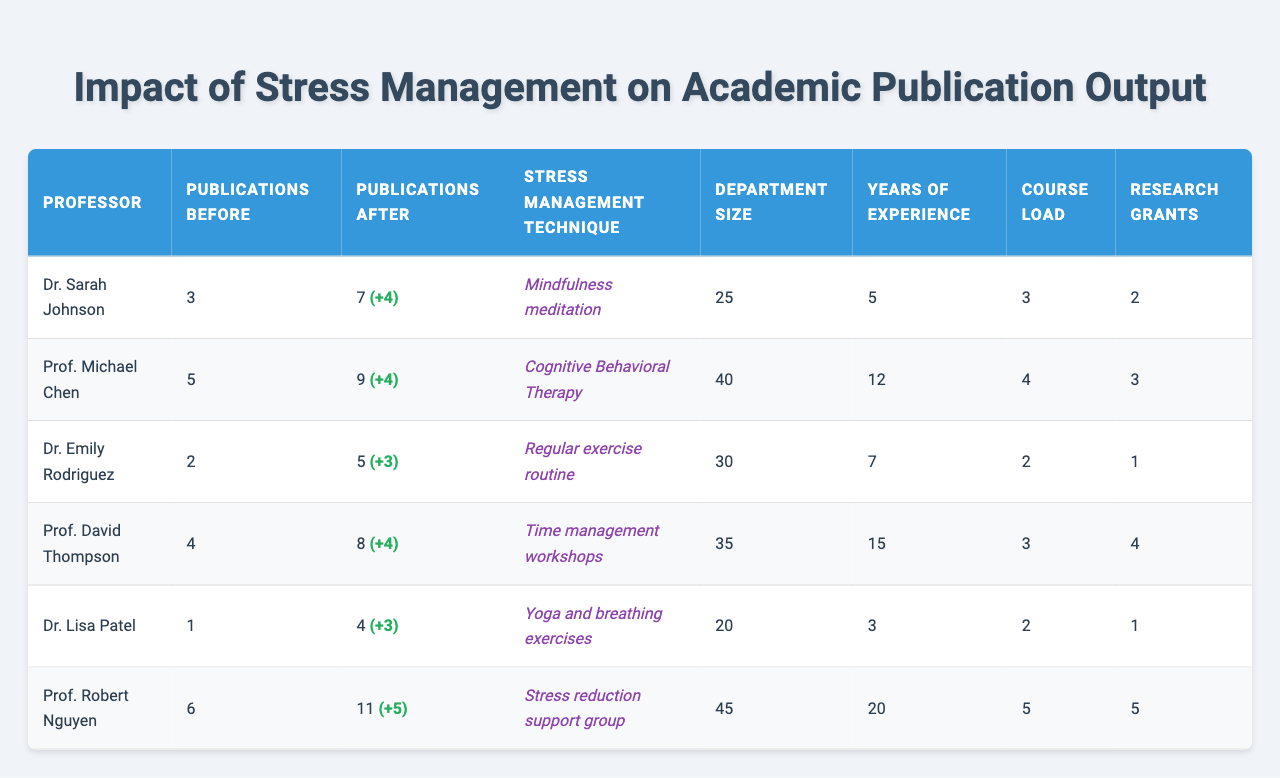What was Dr. Sarah Johnson's publication output before implementing stress management techniques? Referring to the table, Dr. Sarah Johnson had 3 publications before implementing the techniques.
Answer: 3 How many additional publications did Prof. Michael Chen achieve after the stress management techniques? Prof. Michael Chen had 5 publications before and 9 after, which means he gained 4 more publications (9 - 5).
Answer: 4 Which professor had the highest number of publications after implementing stress management? Prof. Robert Nguyen had the highest number, with 11 publications after implementing the techniques.
Answer: Prof. Robert Nguyen Did Dr. Lisa Patel have more publications after the techniques than before? Dr. Lisa Patel had 1 publication before and 4 after, indicating an increase.
Answer: Yes What is the average number of publications before the techniques for all professors combined? The total publications before are 3 + 5 + 2 + 4 + 1 + 6 = 21, and with 6 professors, the average is 21/6 which equals 3.5.
Answer: 3.5 How many professors improved their publication output after the techniques? Dr. Sarah Johnson, Prof. Michael Chen, Prof. David Thompson, Dr. Lisa Patel, and Prof. Robert Nguyen all increased their publications, totaling 5 out of 6.
Answer: 5 What is the difference in research grants obtained between the professor with the most grants and the one with the least? Prof. Robert Nguyen obtained 5 grants and Dr. Emily Rodriguez obtained 1 grant, resulting in a difference of 4 grants (5 - 1).
Answer: 4 Is there a correlation between years of experience and publications after implementing stress management techniques? Prof. Robert Nguyen, with 20 years of experience, had the highest publications (11), while Dr. Lisa Patel, with 3 years, had 4 publications. This suggests more experience may lead to higher publication output, but further statistical analysis would be needed to confirm correlation.
Answer: More experience tends to lead to more publications What was the publication output of Prof. David Thompson after stress management techniques? Prof. David Thompson had 8 publications after implementing the stress management techniques.
Answer: 8 Which stress management technique correlates with the highest publication output? Prof. Robert Nguyen used a stress reduction support group and had 11 publications, which is the highest output observed.
Answer: Stress reduction support group 